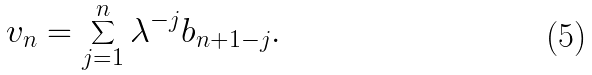Convert formula to latex. <formula><loc_0><loc_0><loc_500><loc_500>v _ { n } = \sum _ { j = 1 } ^ { n } \lambda ^ { - j } b _ { n + 1 - j } .</formula> 